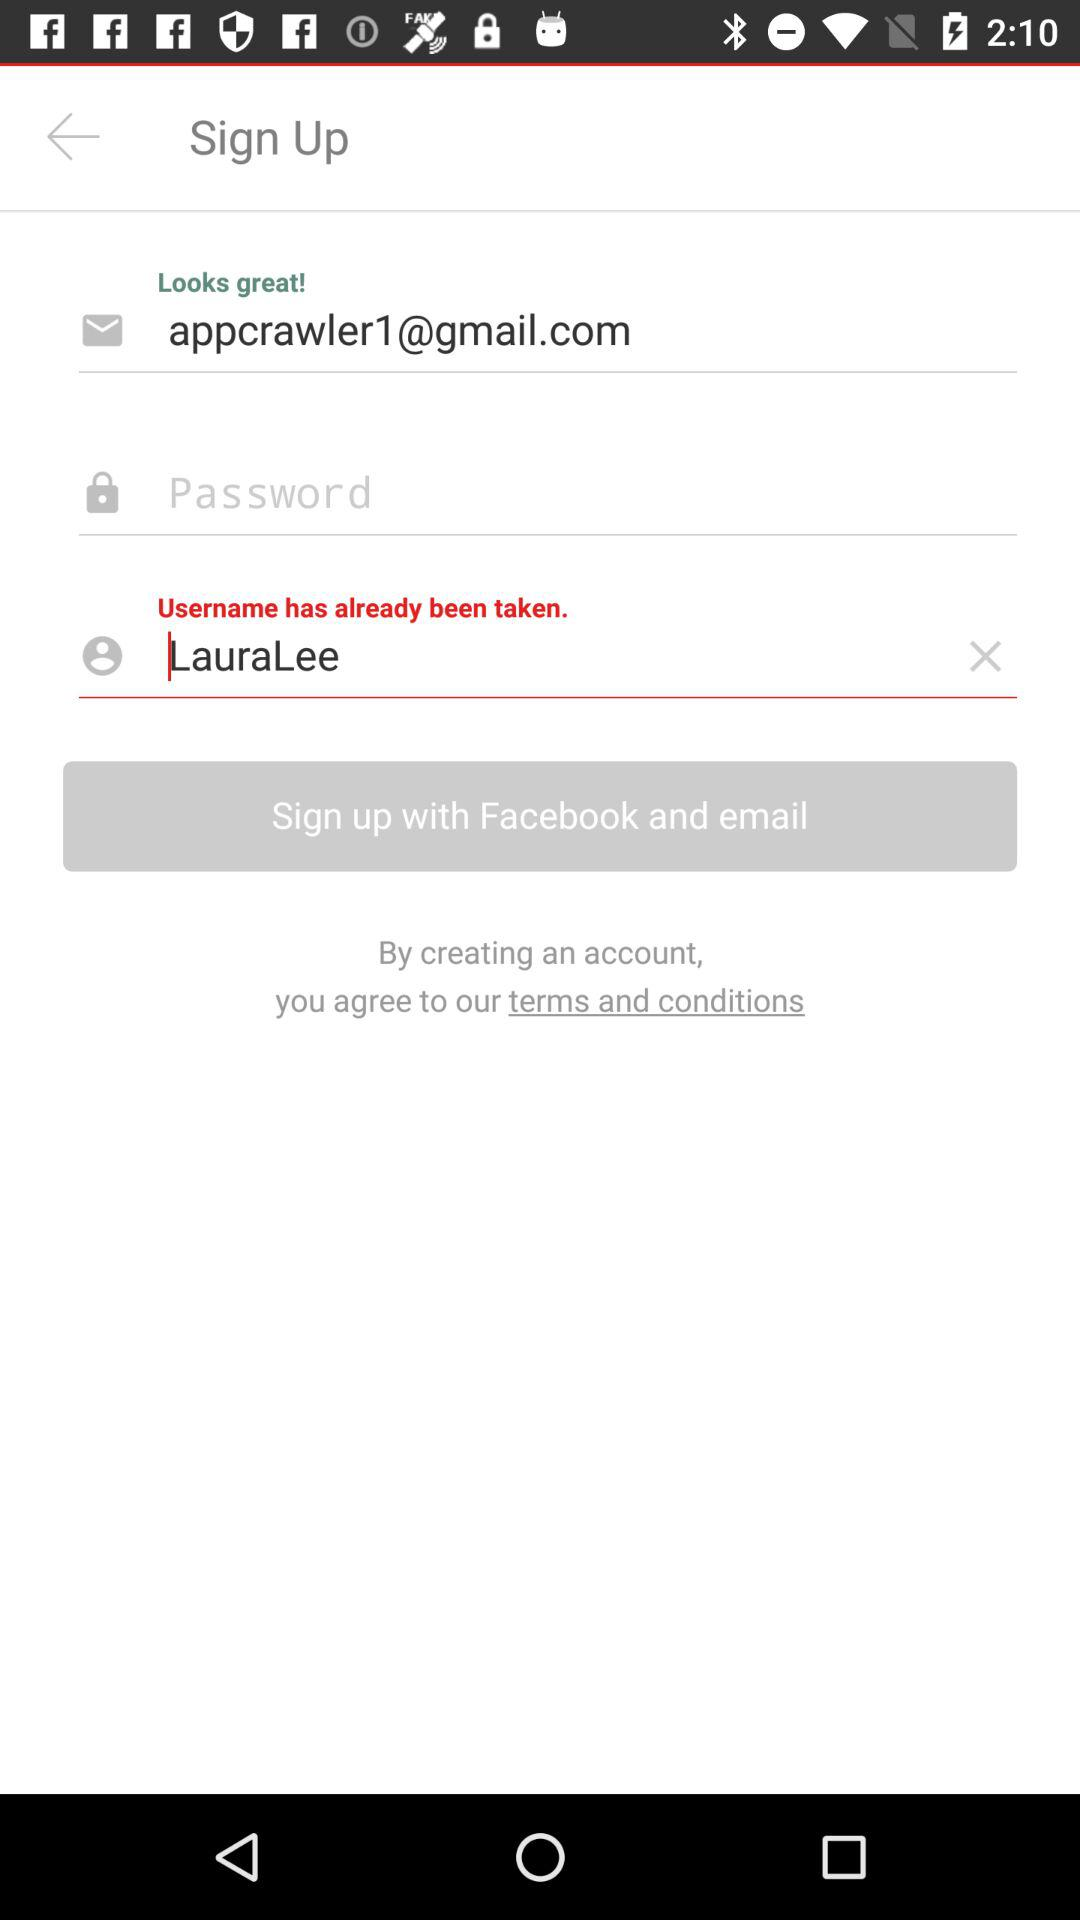What username has already been taken? The username that has already been taken is "LauraLee". 